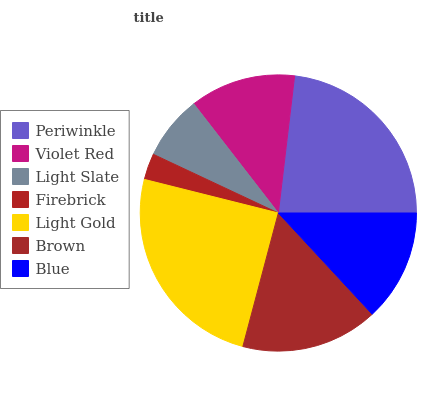Is Firebrick the minimum?
Answer yes or no. Yes. Is Light Gold the maximum?
Answer yes or no. Yes. Is Violet Red the minimum?
Answer yes or no. No. Is Violet Red the maximum?
Answer yes or no. No. Is Periwinkle greater than Violet Red?
Answer yes or no. Yes. Is Violet Red less than Periwinkle?
Answer yes or no. Yes. Is Violet Red greater than Periwinkle?
Answer yes or no. No. Is Periwinkle less than Violet Red?
Answer yes or no. No. Is Blue the high median?
Answer yes or no. Yes. Is Blue the low median?
Answer yes or no. Yes. Is Brown the high median?
Answer yes or no. No. Is Violet Red the low median?
Answer yes or no. No. 